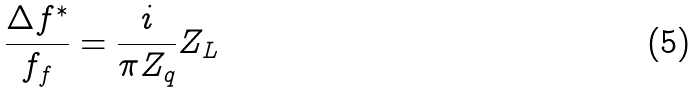<formula> <loc_0><loc_0><loc_500><loc_500>\frac { \Delta f ^ { * } } { f _ { f } } = \frac { i } { \pi Z _ { q } } Z _ { L }</formula> 